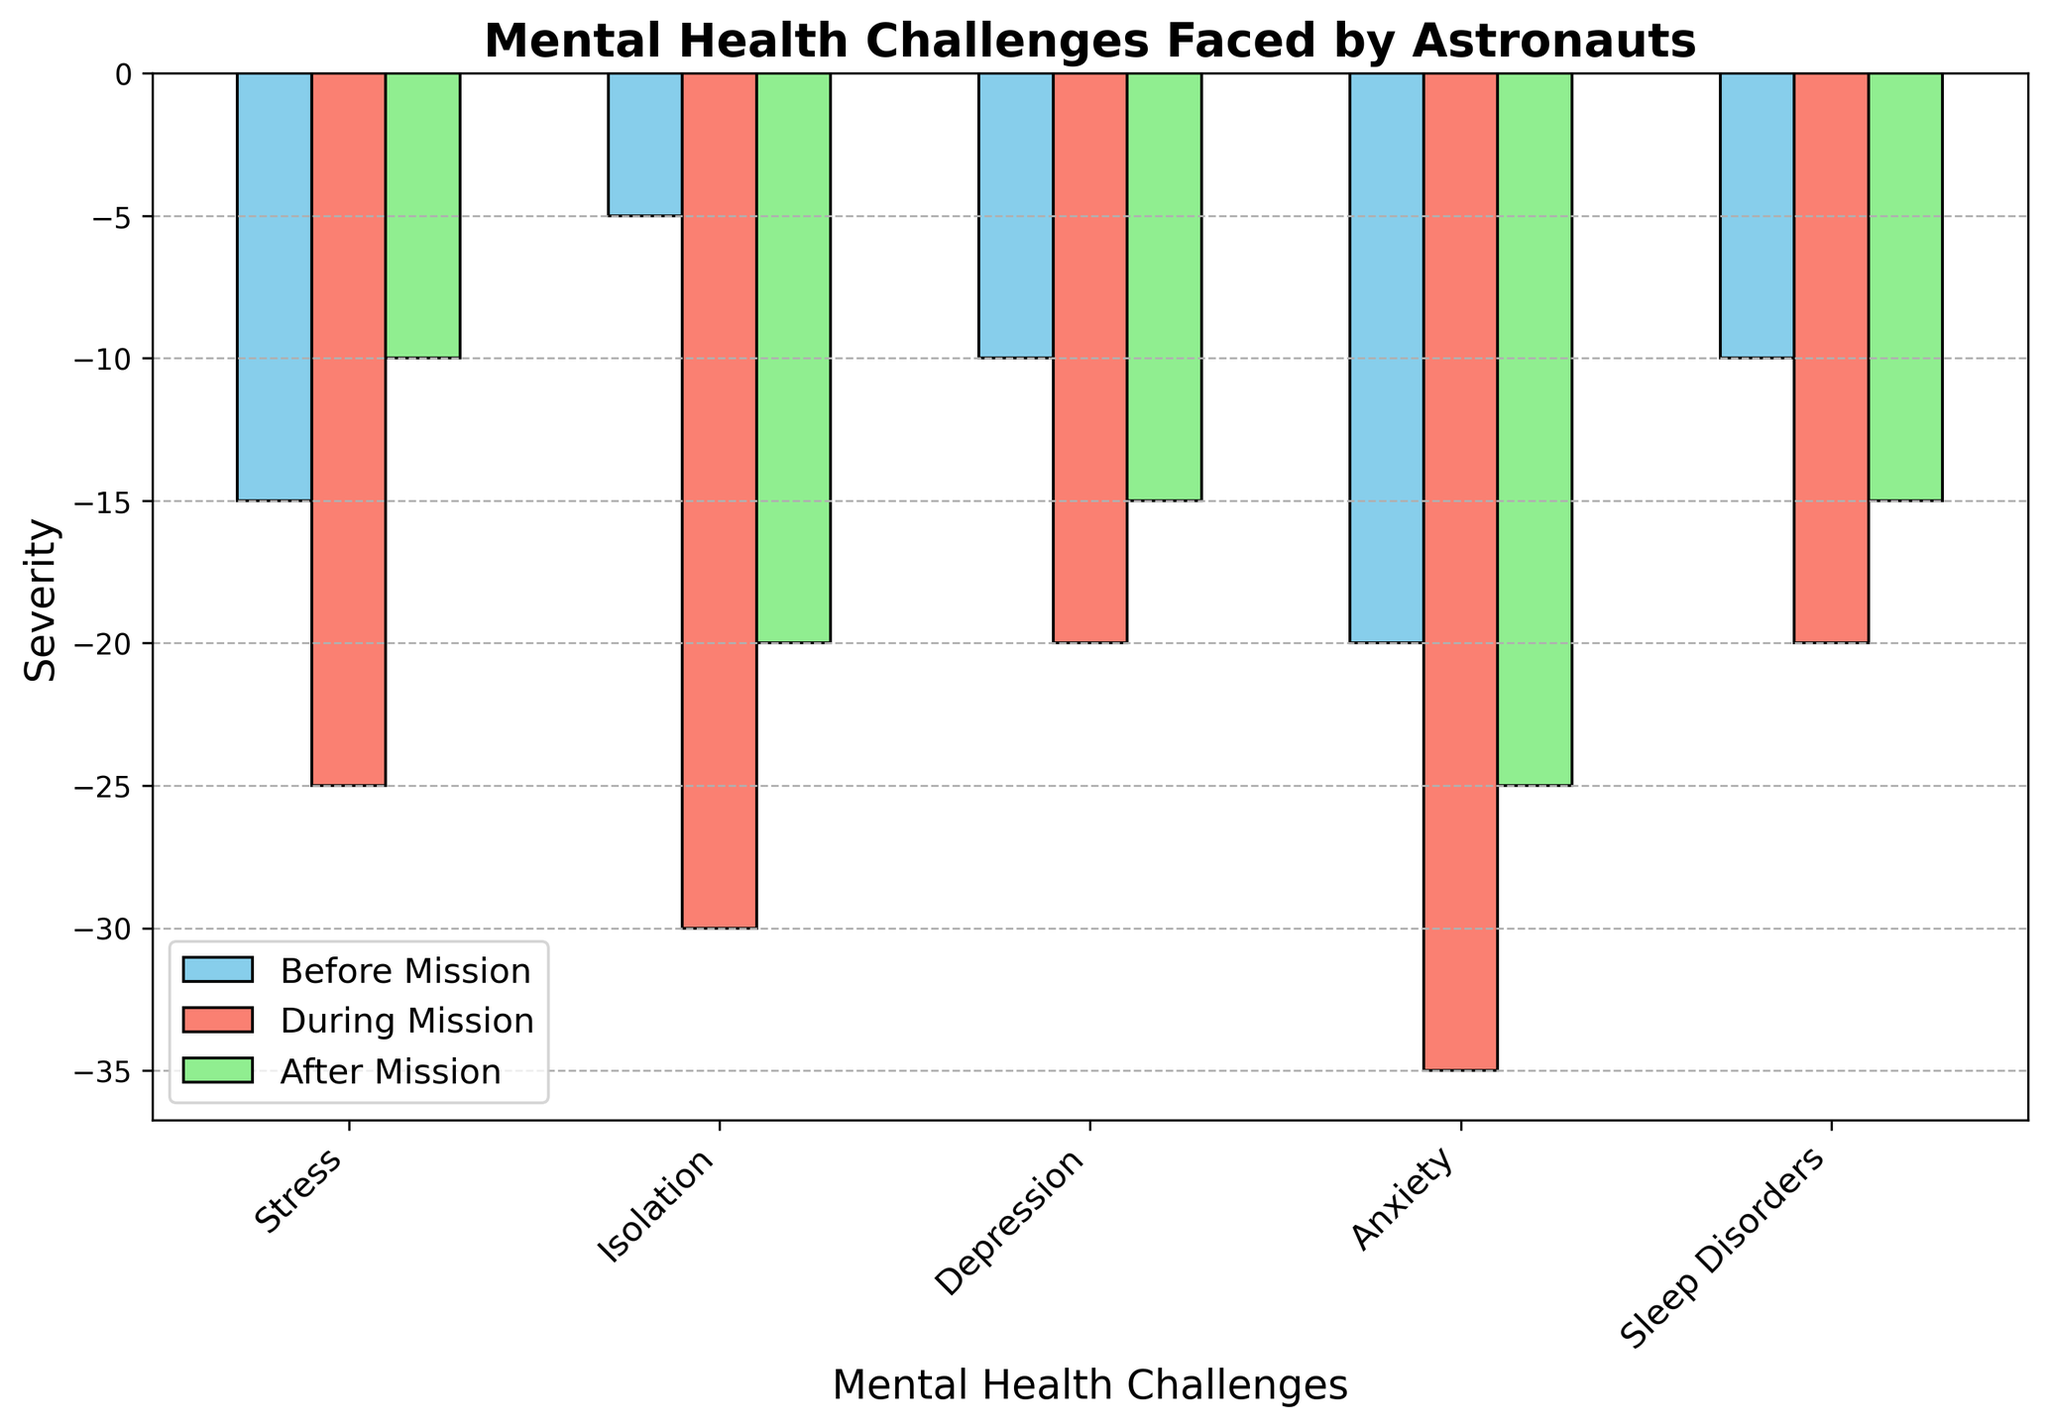What is the difference in severity of Stress faced by astronauts during and before the mission? To find the difference, subtract the severity before the mission from the severity during the mission: -25 - (-15) = -25 + 15 = -10
Answer: -10 Which mental health challenge has the highest severity during the mission? Look for the category with the longest bar in the "During Mission" column. Anxiety has the value -35, which is the highest severity during the mission.
Answer: Anxiety Compare the severity of Isolation and Sleep Disorders after the mission. Which one is higher? Look at the bars for Isolation and Sleep Disorders in the "After Mission" column. Isolation has a severity of -20, and Sleep Disorders have a severity of -15, so Isolation is higher.
Answer: Isolation What is the average severity of Depression faced by astronauts before, during, and after the mission? To find the average, add the severities and divide by the number of periods: (-10 + -20 + -15) / 3 = -45 / 3 = -15
Answer: -15 Calculate the total severity of Anxiety before, during, and after the mission. Add the severities for Anxiety in each period: -20 + -35 + -25 = -80
Answer: -80 Which period shows the greatest variability in severity among the different mental health challenges? Look at the spread of values in each period. The "During Mission" period ranges from -20 to -35, showing the greatest variability (15 units).
Answer: During Mission Which mental health challenge shows the least change in severity before and after the mission? Calculate the difference for each challenge: Stress (-15 to -10 = 5), Isolation (-5 to -20 = 15), Depression (-10 to -15 = 5), Anxiety (-20 to -25 = 5), Sleep Disorders (-10 to -15 = 5). Stress, Depression, Anxiety, and Sleep Disorders all show the least change of 5 units.
Answer: Stress, Depression, Anxiety, Sleep Disorders Which category had a more significant increase in severity from before to during the mission: Anxiety or Isolation? Calculate the change for each category: Anxiety (-35 - (-20) = -15), Isolation (-30 - (-5) = -25). Isolation shows a greater increase in severity.
Answer: Isolation What is the combined severity of Sleep Disorders across all periods? Add the severities for Sleep Disorders: -10 + -20 + -15 = -45
Answer: -45 